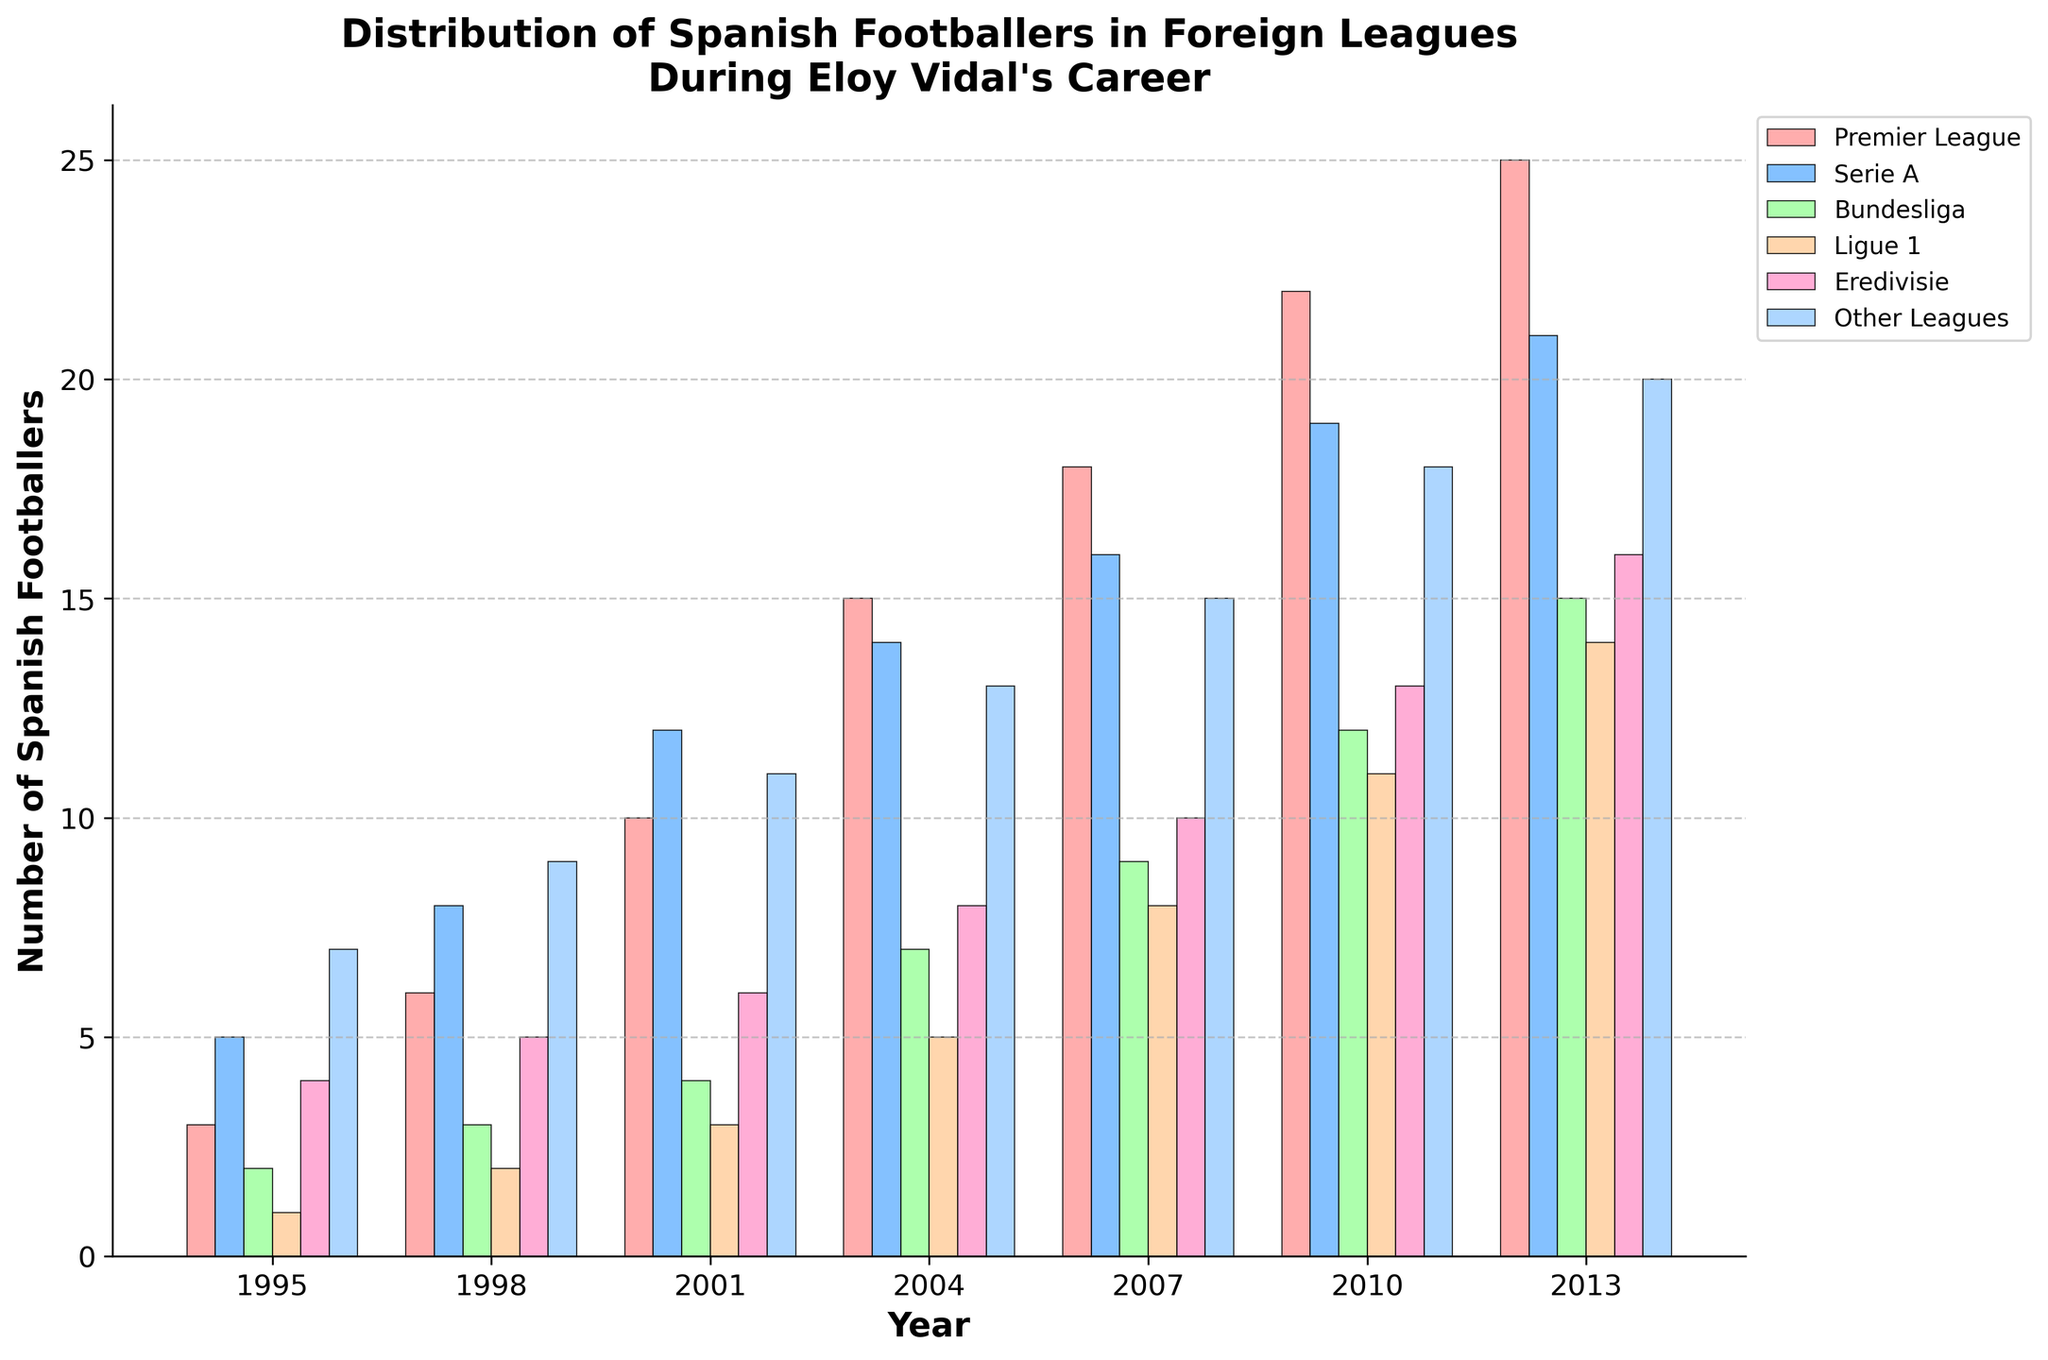Which year had the highest number of Spanish footballers in the Premier League? Look at the bars corresponding to the Premier League category and identify the tallest one. The tallest bar in the Premier League category is in the year 2013.
Answer: 2013 What was the total number of Spanish footballers across all leagues in 2007? Sum the number of Spanish footballers in each league for the year 2007. This includes Premier League (18), Serie A (16), Bundesliga (9), Ligue 1 (8), Eredivisie (10), and Other Leagues (15). The total is 18 + 16 + 9 + 8 + 10 + 15 = 76.
Answer: 76 Which league had the smallest increase in the number of Spanish footballers from 1995 to 2013? Determine the increase for each league by subtracting the counts in 1995 from those in 2013. The increases are Premier League (25-3=22), Serie A (21-5=16), Bundesliga (15-2=13), Ligue 1 (14-1=13), Eredivisie (16-4=12), Other Leagues (20-7=13). The smallest increase is in the Eredivisie.
Answer: Eredivisie In which year did the Bundesliga have exactly twice the number of Spanish footballers compared to the Premier League? Compare the number of Spanish footballers in the Premier League and Bundesliga year by year to find when Bundesliga was twice the Premier League. In 2001, Bundesliga had 4 players and Premier League had 10 (4 is not twice of 10). Therefore, no such year exists.
Answer: None During which year did the Ligue 1 have more than 10 Spanish footballers for the first time? Observe the numbers in Ligue 1 category and identify the first year when they exceed 10. That year is 2010, which had 11 Spanish footballers.
Answer: 2010 How many Spanish footballers played in Serie A and Ligue 1 combined in 2004? Add the number of Spanish footballers in Serie A and Ligue 1 for the year 2004. Serie A had 14 and Ligue 1 had 5. So, the total is 14 + 5 = 19.
Answer: 19 In which league and year did the number of Spanish footballers triple compared to 1995? Compare the numbers for each league from 1995 to all other years to see if they triple at any point. For example, in the Premier League, tripling 1995’s count (3) would be 9; it triples in 2001 (10). Similarly, Serie A from 1995 to 2004 (5 to 15).
Answer: Premier League in 2001, Serie A in 2004 How many years had more than 10 Spanish footballers in Eredivisie? Count the years where the number of Spanish footballers in Eredivisie exceeded 10. For Eredivisie, these are 2010 (13) and 2013 (16).
Answer: 2 